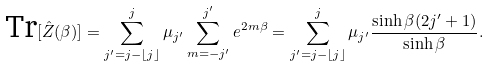<formula> <loc_0><loc_0><loc_500><loc_500>\text {Tr} [ \hat { Z } ( \beta ) ] = \sum _ { j ^ { \prime } = j - \lfloor j \rfloor } ^ { j } \mu _ { j ^ { \prime } } \sum _ { m = - j ^ { \prime } } ^ { j ^ { \prime } } e ^ { 2 m \beta } = \sum _ { j ^ { \prime } = j - \lfloor j \rfloor } ^ { j } \mu _ { j ^ { \prime } } \frac { \sinh \beta ( 2 j ^ { \prime } + 1 ) } { \sinh \beta } .</formula> 